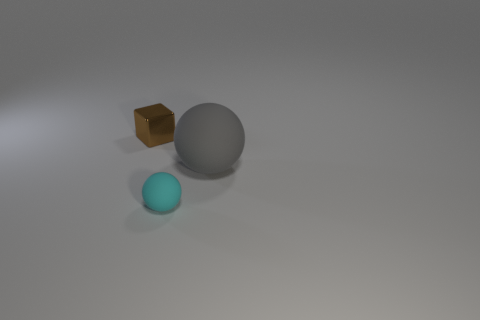Add 1 small blocks. How many objects exist? 4 Subtract all balls. How many objects are left? 1 Add 2 tiny brown blocks. How many tiny brown blocks are left? 3 Add 1 gray things. How many gray things exist? 2 Subtract 0 gray cylinders. How many objects are left? 3 Subtract all big gray spheres. Subtract all tiny brown things. How many objects are left? 1 